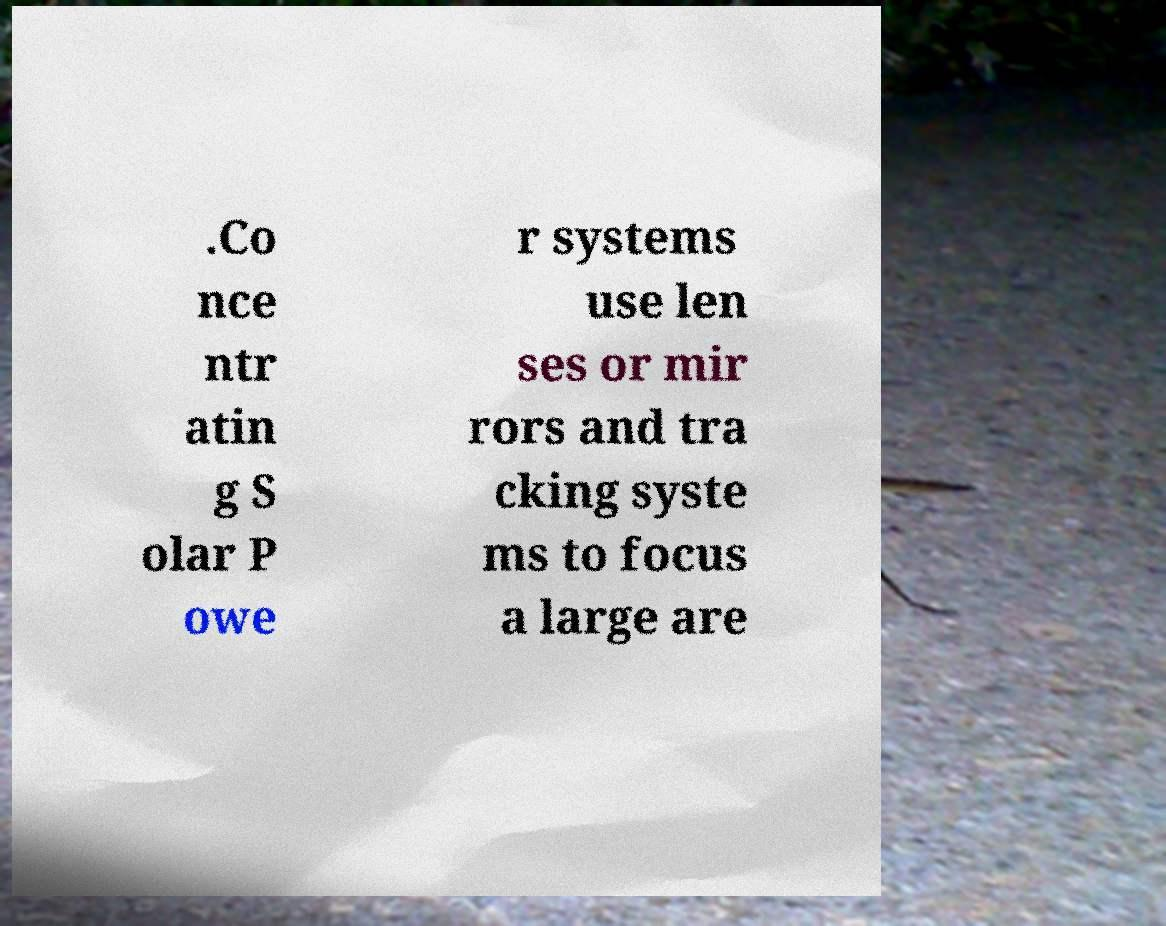Could you assist in decoding the text presented in this image and type it out clearly? .Co nce ntr atin g S olar P owe r systems use len ses or mir rors and tra cking syste ms to focus a large are 